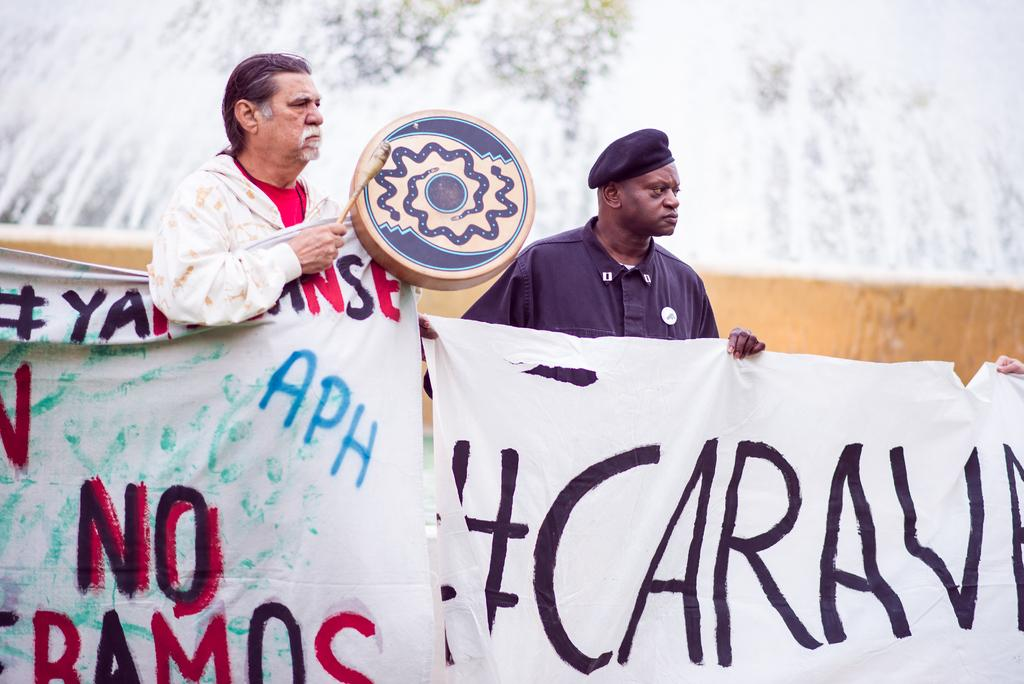How many people are in the image? There are two men in the image. What are the men doing in the image? The men are standing and holding advertisements in their hands. Can you describe any additional objects the men are holding? One of the men is holding a drum in his hands. What type of bean is being advertised in the image? There is no bean being advertised in the image; the men are holding advertisements, but the content of those advertisements is not visible. 